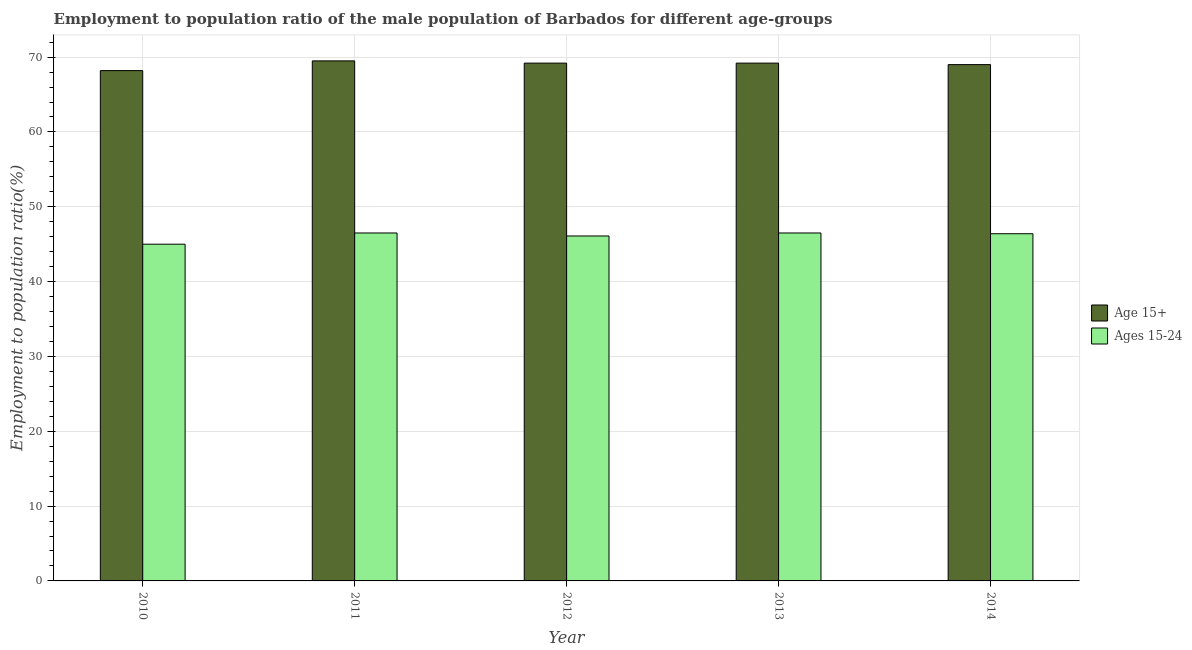How many groups of bars are there?
Your answer should be very brief. 5. Are the number of bars per tick equal to the number of legend labels?
Provide a succinct answer. Yes. What is the label of the 3rd group of bars from the left?
Give a very brief answer. 2012. What is the employment to population ratio(age 15+) in 2013?
Give a very brief answer. 69.2. Across all years, what is the maximum employment to population ratio(age 15-24)?
Offer a terse response. 46.5. What is the total employment to population ratio(age 15+) in the graph?
Ensure brevity in your answer.  345.1. What is the difference between the employment to population ratio(age 15-24) in 2011 and the employment to population ratio(age 15+) in 2013?
Make the answer very short. 0. What is the average employment to population ratio(age 15-24) per year?
Offer a very short reply. 46.1. What is the ratio of the employment to population ratio(age 15+) in 2012 to that in 2013?
Your answer should be very brief. 1. Is the employment to population ratio(age 15-24) in 2010 less than that in 2013?
Ensure brevity in your answer.  Yes. Is the difference between the employment to population ratio(age 15+) in 2011 and 2014 greater than the difference between the employment to population ratio(age 15-24) in 2011 and 2014?
Your response must be concise. No. What is the difference between the highest and the second highest employment to population ratio(age 15+)?
Offer a very short reply. 0.3. What is the difference between the highest and the lowest employment to population ratio(age 15+)?
Give a very brief answer. 1.3. In how many years, is the employment to population ratio(age 15+) greater than the average employment to population ratio(age 15+) taken over all years?
Provide a short and direct response. 3. Is the sum of the employment to population ratio(age 15+) in 2012 and 2014 greater than the maximum employment to population ratio(age 15-24) across all years?
Keep it short and to the point. Yes. What does the 2nd bar from the left in 2014 represents?
Ensure brevity in your answer.  Ages 15-24. What does the 1st bar from the right in 2014 represents?
Your answer should be compact. Ages 15-24. How many bars are there?
Keep it short and to the point. 10. Are all the bars in the graph horizontal?
Make the answer very short. No. What is the difference between two consecutive major ticks on the Y-axis?
Give a very brief answer. 10. Are the values on the major ticks of Y-axis written in scientific E-notation?
Provide a succinct answer. No. Does the graph contain any zero values?
Ensure brevity in your answer.  No. Does the graph contain grids?
Your answer should be very brief. Yes. How many legend labels are there?
Your answer should be compact. 2. What is the title of the graph?
Provide a succinct answer. Employment to population ratio of the male population of Barbados for different age-groups. What is the label or title of the X-axis?
Your response must be concise. Year. What is the label or title of the Y-axis?
Your response must be concise. Employment to population ratio(%). What is the Employment to population ratio(%) in Age 15+ in 2010?
Your answer should be very brief. 68.2. What is the Employment to population ratio(%) in Ages 15-24 in 2010?
Keep it short and to the point. 45. What is the Employment to population ratio(%) of Age 15+ in 2011?
Give a very brief answer. 69.5. What is the Employment to population ratio(%) in Ages 15-24 in 2011?
Keep it short and to the point. 46.5. What is the Employment to population ratio(%) in Age 15+ in 2012?
Make the answer very short. 69.2. What is the Employment to population ratio(%) in Ages 15-24 in 2012?
Your answer should be very brief. 46.1. What is the Employment to population ratio(%) in Age 15+ in 2013?
Provide a succinct answer. 69.2. What is the Employment to population ratio(%) of Ages 15-24 in 2013?
Make the answer very short. 46.5. What is the Employment to population ratio(%) of Ages 15-24 in 2014?
Ensure brevity in your answer.  46.4. Across all years, what is the maximum Employment to population ratio(%) in Age 15+?
Provide a short and direct response. 69.5. Across all years, what is the maximum Employment to population ratio(%) of Ages 15-24?
Keep it short and to the point. 46.5. Across all years, what is the minimum Employment to population ratio(%) in Age 15+?
Ensure brevity in your answer.  68.2. Across all years, what is the minimum Employment to population ratio(%) of Ages 15-24?
Make the answer very short. 45. What is the total Employment to population ratio(%) of Age 15+ in the graph?
Make the answer very short. 345.1. What is the total Employment to population ratio(%) of Ages 15-24 in the graph?
Make the answer very short. 230.5. What is the difference between the Employment to population ratio(%) in Ages 15-24 in 2010 and that in 2014?
Make the answer very short. -1.4. What is the difference between the Employment to population ratio(%) of Age 15+ in 2011 and that in 2012?
Provide a succinct answer. 0.3. What is the difference between the Employment to population ratio(%) in Ages 15-24 in 2011 and that in 2012?
Ensure brevity in your answer.  0.4. What is the difference between the Employment to population ratio(%) of Age 15+ in 2011 and that in 2013?
Provide a succinct answer. 0.3. What is the difference between the Employment to population ratio(%) in Age 15+ in 2011 and that in 2014?
Your answer should be very brief. 0.5. What is the difference between the Employment to population ratio(%) in Age 15+ in 2012 and that in 2013?
Your answer should be very brief. 0. What is the difference between the Employment to population ratio(%) in Ages 15-24 in 2012 and that in 2013?
Your response must be concise. -0.4. What is the difference between the Employment to population ratio(%) of Age 15+ in 2012 and that in 2014?
Offer a very short reply. 0.2. What is the difference between the Employment to population ratio(%) of Ages 15-24 in 2012 and that in 2014?
Your response must be concise. -0.3. What is the difference between the Employment to population ratio(%) of Ages 15-24 in 2013 and that in 2014?
Ensure brevity in your answer.  0.1. What is the difference between the Employment to population ratio(%) in Age 15+ in 2010 and the Employment to population ratio(%) in Ages 15-24 in 2011?
Provide a short and direct response. 21.7. What is the difference between the Employment to population ratio(%) of Age 15+ in 2010 and the Employment to population ratio(%) of Ages 15-24 in 2012?
Keep it short and to the point. 22.1. What is the difference between the Employment to population ratio(%) of Age 15+ in 2010 and the Employment to population ratio(%) of Ages 15-24 in 2013?
Provide a short and direct response. 21.7. What is the difference between the Employment to population ratio(%) in Age 15+ in 2010 and the Employment to population ratio(%) in Ages 15-24 in 2014?
Ensure brevity in your answer.  21.8. What is the difference between the Employment to population ratio(%) in Age 15+ in 2011 and the Employment to population ratio(%) in Ages 15-24 in 2012?
Your answer should be compact. 23.4. What is the difference between the Employment to population ratio(%) in Age 15+ in 2011 and the Employment to population ratio(%) in Ages 15-24 in 2013?
Offer a very short reply. 23. What is the difference between the Employment to population ratio(%) of Age 15+ in 2011 and the Employment to population ratio(%) of Ages 15-24 in 2014?
Your answer should be compact. 23.1. What is the difference between the Employment to population ratio(%) of Age 15+ in 2012 and the Employment to population ratio(%) of Ages 15-24 in 2013?
Give a very brief answer. 22.7. What is the difference between the Employment to population ratio(%) of Age 15+ in 2012 and the Employment to population ratio(%) of Ages 15-24 in 2014?
Offer a very short reply. 22.8. What is the difference between the Employment to population ratio(%) in Age 15+ in 2013 and the Employment to population ratio(%) in Ages 15-24 in 2014?
Ensure brevity in your answer.  22.8. What is the average Employment to population ratio(%) of Age 15+ per year?
Keep it short and to the point. 69.02. What is the average Employment to population ratio(%) of Ages 15-24 per year?
Ensure brevity in your answer.  46.1. In the year 2010, what is the difference between the Employment to population ratio(%) in Age 15+ and Employment to population ratio(%) in Ages 15-24?
Provide a succinct answer. 23.2. In the year 2012, what is the difference between the Employment to population ratio(%) in Age 15+ and Employment to population ratio(%) in Ages 15-24?
Your answer should be compact. 23.1. In the year 2013, what is the difference between the Employment to population ratio(%) of Age 15+ and Employment to population ratio(%) of Ages 15-24?
Provide a succinct answer. 22.7. In the year 2014, what is the difference between the Employment to population ratio(%) in Age 15+ and Employment to population ratio(%) in Ages 15-24?
Offer a terse response. 22.6. What is the ratio of the Employment to population ratio(%) in Age 15+ in 2010 to that in 2011?
Ensure brevity in your answer.  0.98. What is the ratio of the Employment to population ratio(%) of Age 15+ in 2010 to that in 2012?
Make the answer very short. 0.99. What is the ratio of the Employment to population ratio(%) in Ages 15-24 in 2010 to that in 2012?
Make the answer very short. 0.98. What is the ratio of the Employment to population ratio(%) of Age 15+ in 2010 to that in 2013?
Your answer should be very brief. 0.99. What is the ratio of the Employment to population ratio(%) of Ages 15-24 in 2010 to that in 2013?
Ensure brevity in your answer.  0.97. What is the ratio of the Employment to population ratio(%) in Age 15+ in 2010 to that in 2014?
Keep it short and to the point. 0.99. What is the ratio of the Employment to population ratio(%) of Ages 15-24 in 2010 to that in 2014?
Your response must be concise. 0.97. What is the ratio of the Employment to population ratio(%) in Ages 15-24 in 2011 to that in 2012?
Your answer should be compact. 1.01. What is the ratio of the Employment to population ratio(%) in Age 15+ in 2011 to that in 2014?
Offer a terse response. 1.01. What is the ratio of the Employment to population ratio(%) of Age 15+ in 2012 to that in 2013?
Give a very brief answer. 1. What is the ratio of the Employment to population ratio(%) of Ages 15-24 in 2012 to that in 2013?
Offer a very short reply. 0.99. What is the ratio of the Employment to population ratio(%) in Ages 15-24 in 2012 to that in 2014?
Your answer should be very brief. 0.99. What is the ratio of the Employment to population ratio(%) of Age 15+ in 2013 to that in 2014?
Keep it short and to the point. 1. What is the ratio of the Employment to population ratio(%) of Ages 15-24 in 2013 to that in 2014?
Your response must be concise. 1. What is the difference between the highest and the second highest Employment to population ratio(%) in Ages 15-24?
Keep it short and to the point. 0. 